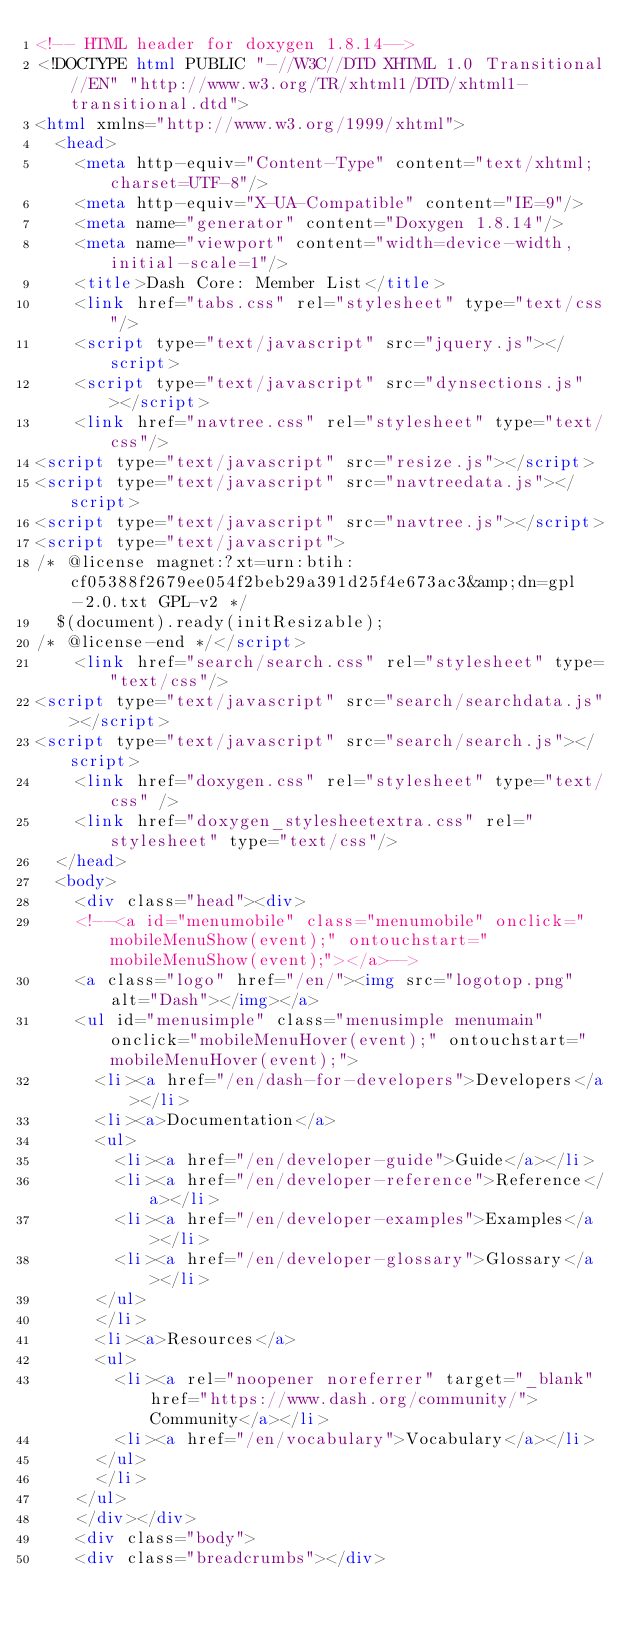Convert code to text. <code><loc_0><loc_0><loc_500><loc_500><_HTML_><!-- HTML header for doxygen 1.8.14-->
<!DOCTYPE html PUBLIC "-//W3C//DTD XHTML 1.0 Transitional//EN" "http://www.w3.org/TR/xhtml1/DTD/xhtml1-transitional.dtd">
<html xmlns="http://www.w3.org/1999/xhtml">
	<head>
		<meta http-equiv="Content-Type" content="text/xhtml;charset=UTF-8"/>
		<meta http-equiv="X-UA-Compatible" content="IE=9"/>
		<meta name="generator" content="Doxygen 1.8.14"/>
		<meta name="viewport" content="width=device-width, initial-scale=1"/>
		<title>Dash Core: Member List</title>
		<link href="tabs.css" rel="stylesheet" type="text/css"/>
		<script type="text/javascript" src="jquery.js"></script>
		<script type="text/javascript" src="dynsections.js"></script>
		<link href="navtree.css" rel="stylesheet" type="text/css"/>
<script type="text/javascript" src="resize.js"></script>
<script type="text/javascript" src="navtreedata.js"></script>
<script type="text/javascript" src="navtree.js"></script>
<script type="text/javascript">
/* @license magnet:?xt=urn:btih:cf05388f2679ee054f2beb29a391d25f4e673ac3&amp;dn=gpl-2.0.txt GPL-v2 */
  $(document).ready(initResizable);
/* @license-end */</script>
		<link href="search/search.css" rel="stylesheet" type="text/css"/>
<script type="text/javascript" src="search/searchdata.js"></script>
<script type="text/javascript" src="search/search.js"></script>
		<link href="doxygen.css" rel="stylesheet" type="text/css" />
		<link href="doxygen_stylesheetextra.css" rel="stylesheet" type="text/css"/>
	</head>
	<body>
		<div class="head"><div>
		<!--<a id="menumobile" class="menumobile" onclick="mobileMenuShow(event);" ontouchstart="mobileMenuShow(event);"></a>-->
		<a class="logo" href="/en/"><img src="logotop.png" alt="Dash"></img></a>
		<ul id="menusimple" class="menusimple menumain" onclick="mobileMenuHover(event);" ontouchstart="mobileMenuHover(event);">
		  <li><a href="/en/dash-for-developers">Developers</a></li>
		  <li><a>Documentation</a>
			<ul>
			  <li><a href="/en/developer-guide">Guide</a></li>
			  <li><a href="/en/developer-reference">Reference</a></li>
			  <li><a href="/en/developer-examples">Examples</a></li>
			  <li><a href="/en/developer-glossary">Glossary</a></li>
			</ul>
		  </li>
		  <li><a>Resources</a>
			<ul>
			  <li><a rel="noopener noreferrer" target="_blank" href="https://www.dash.org/community/">Community</a></li>
			  <li><a href="/en/vocabulary">Vocabulary</a></li>
			</ul>
		  </li>
		</ul>
		</div></div>
		<div class="body">
		<div class="breadcrumbs"></div></code> 